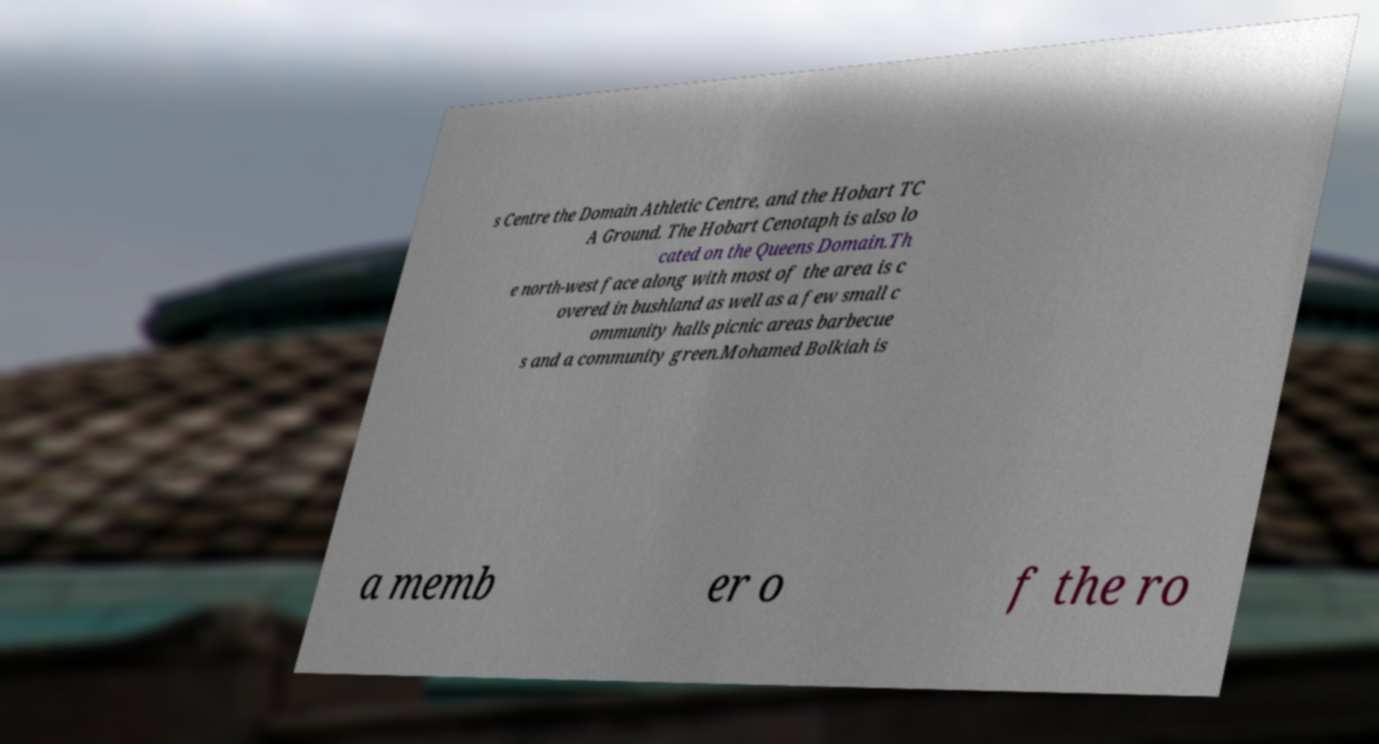Could you assist in decoding the text presented in this image and type it out clearly? s Centre the Domain Athletic Centre, and the Hobart TC A Ground. The Hobart Cenotaph is also lo cated on the Queens Domain.Th e north-west face along with most of the area is c overed in bushland as well as a few small c ommunity halls picnic areas barbecue s and a community green.Mohamed Bolkiah is a memb er o f the ro 